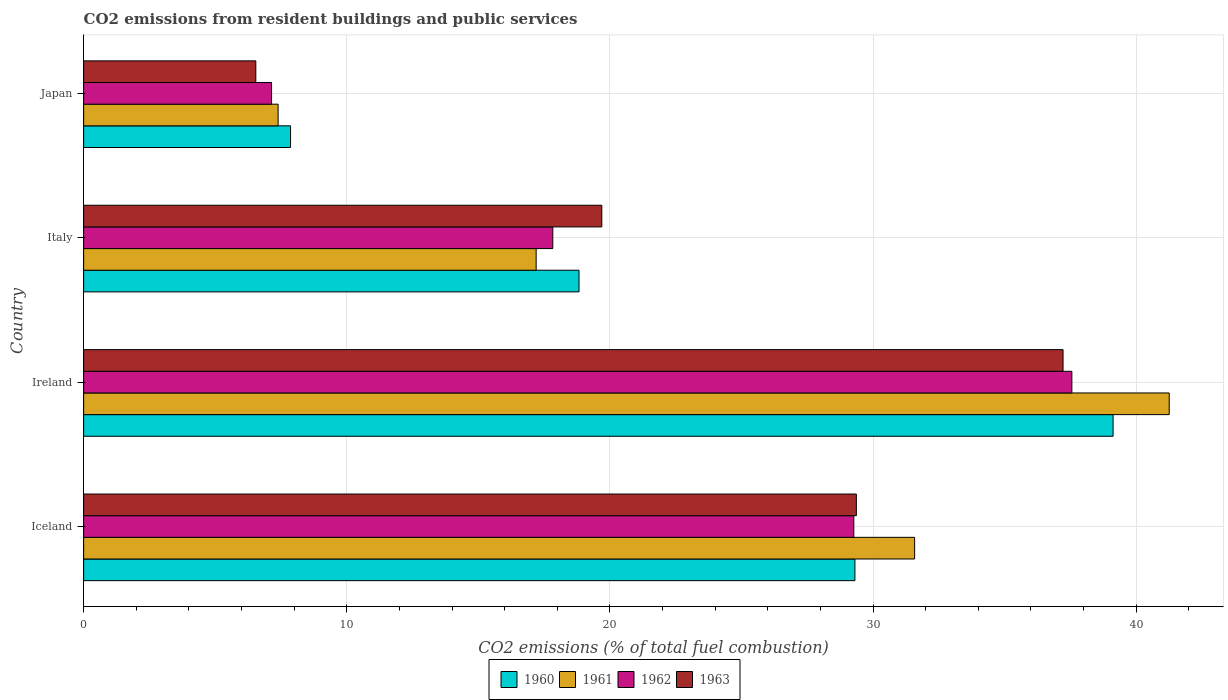How many bars are there on the 2nd tick from the bottom?
Provide a short and direct response. 4. What is the total CO2 emitted in 1962 in Japan?
Offer a terse response. 7.14. Across all countries, what is the maximum total CO2 emitted in 1962?
Offer a very short reply. 37.55. Across all countries, what is the minimum total CO2 emitted in 1962?
Provide a short and direct response. 7.14. In which country was the total CO2 emitted in 1960 maximum?
Your answer should be compact. Ireland. What is the total total CO2 emitted in 1960 in the graph?
Your answer should be very brief. 95.12. What is the difference between the total CO2 emitted in 1960 in Ireland and that in Italy?
Offer a very short reply. 20.29. What is the difference between the total CO2 emitted in 1960 in Japan and the total CO2 emitted in 1961 in Iceland?
Provide a succinct answer. -23.72. What is the average total CO2 emitted in 1961 per country?
Your response must be concise. 24.36. What is the difference between the total CO2 emitted in 1960 and total CO2 emitted in 1963 in Iceland?
Give a very brief answer. -0.05. In how many countries, is the total CO2 emitted in 1960 greater than 26 ?
Offer a terse response. 2. What is the ratio of the total CO2 emitted in 1960 in Iceland to that in Italy?
Give a very brief answer. 1.56. Is the total CO2 emitted in 1962 in Italy less than that in Japan?
Your answer should be compact. No. What is the difference between the highest and the second highest total CO2 emitted in 1962?
Your answer should be compact. 8.29. What is the difference between the highest and the lowest total CO2 emitted in 1960?
Provide a succinct answer. 31.26. Is the sum of the total CO2 emitted in 1961 in Ireland and Italy greater than the maximum total CO2 emitted in 1960 across all countries?
Ensure brevity in your answer.  Yes. Is it the case that in every country, the sum of the total CO2 emitted in 1962 and total CO2 emitted in 1961 is greater than the sum of total CO2 emitted in 1963 and total CO2 emitted in 1960?
Provide a succinct answer. No. Is it the case that in every country, the sum of the total CO2 emitted in 1961 and total CO2 emitted in 1963 is greater than the total CO2 emitted in 1962?
Your answer should be very brief. Yes. Are all the bars in the graph horizontal?
Make the answer very short. Yes. Are the values on the major ticks of X-axis written in scientific E-notation?
Offer a terse response. No. Where does the legend appear in the graph?
Provide a short and direct response. Bottom center. What is the title of the graph?
Provide a succinct answer. CO2 emissions from resident buildings and public services. What is the label or title of the X-axis?
Keep it short and to the point. CO2 emissions (% of total fuel combustion). What is the label or title of the Y-axis?
Offer a terse response. Country. What is the CO2 emissions (% of total fuel combustion) in 1960 in Iceland?
Ensure brevity in your answer.  29.31. What is the CO2 emissions (% of total fuel combustion) in 1961 in Iceland?
Ensure brevity in your answer.  31.58. What is the CO2 emissions (% of total fuel combustion) in 1962 in Iceland?
Your response must be concise. 29.27. What is the CO2 emissions (% of total fuel combustion) of 1963 in Iceland?
Offer a very short reply. 29.37. What is the CO2 emissions (% of total fuel combustion) of 1960 in Ireland?
Your answer should be compact. 39.12. What is the CO2 emissions (% of total fuel combustion) in 1961 in Ireland?
Ensure brevity in your answer.  41.25. What is the CO2 emissions (% of total fuel combustion) of 1962 in Ireland?
Ensure brevity in your answer.  37.55. What is the CO2 emissions (% of total fuel combustion) of 1963 in Ireland?
Ensure brevity in your answer.  37.22. What is the CO2 emissions (% of total fuel combustion) in 1960 in Italy?
Your answer should be very brief. 18.83. What is the CO2 emissions (% of total fuel combustion) in 1961 in Italy?
Keep it short and to the point. 17.2. What is the CO2 emissions (% of total fuel combustion) of 1962 in Italy?
Give a very brief answer. 17.83. What is the CO2 emissions (% of total fuel combustion) in 1963 in Italy?
Offer a terse response. 19.69. What is the CO2 emissions (% of total fuel combustion) in 1960 in Japan?
Ensure brevity in your answer.  7.86. What is the CO2 emissions (% of total fuel combustion) of 1961 in Japan?
Your answer should be very brief. 7.39. What is the CO2 emissions (% of total fuel combustion) of 1962 in Japan?
Offer a very short reply. 7.14. What is the CO2 emissions (% of total fuel combustion) in 1963 in Japan?
Offer a very short reply. 6.54. Across all countries, what is the maximum CO2 emissions (% of total fuel combustion) of 1960?
Your response must be concise. 39.12. Across all countries, what is the maximum CO2 emissions (% of total fuel combustion) of 1961?
Make the answer very short. 41.25. Across all countries, what is the maximum CO2 emissions (% of total fuel combustion) of 1962?
Provide a short and direct response. 37.55. Across all countries, what is the maximum CO2 emissions (% of total fuel combustion) of 1963?
Your response must be concise. 37.22. Across all countries, what is the minimum CO2 emissions (% of total fuel combustion) of 1960?
Keep it short and to the point. 7.86. Across all countries, what is the minimum CO2 emissions (% of total fuel combustion) in 1961?
Offer a very short reply. 7.39. Across all countries, what is the minimum CO2 emissions (% of total fuel combustion) of 1962?
Make the answer very short. 7.14. Across all countries, what is the minimum CO2 emissions (% of total fuel combustion) of 1963?
Your answer should be very brief. 6.54. What is the total CO2 emissions (% of total fuel combustion) of 1960 in the graph?
Your answer should be very brief. 95.12. What is the total CO2 emissions (% of total fuel combustion) in 1961 in the graph?
Ensure brevity in your answer.  97.42. What is the total CO2 emissions (% of total fuel combustion) in 1962 in the graph?
Your response must be concise. 91.79. What is the total CO2 emissions (% of total fuel combustion) in 1963 in the graph?
Your answer should be very brief. 92.82. What is the difference between the CO2 emissions (% of total fuel combustion) of 1960 in Iceland and that in Ireland?
Your response must be concise. -9.81. What is the difference between the CO2 emissions (% of total fuel combustion) of 1961 in Iceland and that in Ireland?
Provide a succinct answer. -9.67. What is the difference between the CO2 emissions (% of total fuel combustion) of 1962 in Iceland and that in Ireland?
Your answer should be compact. -8.29. What is the difference between the CO2 emissions (% of total fuel combustion) in 1963 in Iceland and that in Ireland?
Your answer should be compact. -7.85. What is the difference between the CO2 emissions (% of total fuel combustion) in 1960 in Iceland and that in Italy?
Keep it short and to the point. 10.48. What is the difference between the CO2 emissions (% of total fuel combustion) of 1961 in Iceland and that in Italy?
Offer a terse response. 14.38. What is the difference between the CO2 emissions (% of total fuel combustion) of 1962 in Iceland and that in Italy?
Offer a terse response. 11.44. What is the difference between the CO2 emissions (% of total fuel combustion) of 1963 in Iceland and that in Italy?
Make the answer very short. 9.67. What is the difference between the CO2 emissions (% of total fuel combustion) in 1960 in Iceland and that in Japan?
Offer a very short reply. 21.45. What is the difference between the CO2 emissions (% of total fuel combustion) in 1961 in Iceland and that in Japan?
Offer a terse response. 24.19. What is the difference between the CO2 emissions (% of total fuel combustion) in 1962 in Iceland and that in Japan?
Make the answer very short. 22.13. What is the difference between the CO2 emissions (% of total fuel combustion) of 1963 in Iceland and that in Japan?
Offer a very short reply. 22.82. What is the difference between the CO2 emissions (% of total fuel combustion) of 1960 in Ireland and that in Italy?
Make the answer very short. 20.29. What is the difference between the CO2 emissions (% of total fuel combustion) in 1961 in Ireland and that in Italy?
Offer a very short reply. 24.06. What is the difference between the CO2 emissions (% of total fuel combustion) of 1962 in Ireland and that in Italy?
Offer a terse response. 19.73. What is the difference between the CO2 emissions (% of total fuel combustion) of 1963 in Ireland and that in Italy?
Ensure brevity in your answer.  17.53. What is the difference between the CO2 emissions (% of total fuel combustion) in 1960 in Ireland and that in Japan?
Your answer should be very brief. 31.26. What is the difference between the CO2 emissions (% of total fuel combustion) in 1961 in Ireland and that in Japan?
Make the answer very short. 33.86. What is the difference between the CO2 emissions (% of total fuel combustion) in 1962 in Ireland and that in Japan?
Your response must be concise. 30.41. What is the difference between the CO2 emissions (% of total fuel combustion) of 1963 in Ireland and that in Japan?
Give a very brief answer. 30.68. What is the difference between the CO2 emissions (% of total fuel combustion) of 1960 in Italy and that in Japan?
Ensure brevity in your answer.  10.96. What is the difference between the CO2 emissions (% of total fuel combustion) of 1961 in Italy and that in Japan?
Keep it short and to the point. 9.81. What is the difference between the CO2 emissions (% of total fuel combustion) in 1962 in Italy and that in Japan?
Offer a terse response. 10.69. What is the difference between the CO2 emissions (% of total fuel combustion) in 1963 in Italy and that in Japan?
Offer a terse response. 13.15. What is the difference between the CO2 emissions (% of total fuel combustion) in 1960 in Iceland and the CO2 emissions (% of total fuel combustion) in 1961 in Ireland?
Provide a short and direct response. -11.94. What is the difference between the CO2 emissions (% of total fuel combustion) in 1960 in Iceland and the CO2 emissions (% of total fuel combustion) in 1962 in Ireland?
Provide a succinct answer. -8.24. What is the difference between the CO2 emissions (% of total fuel combustion) in 1960 in Iceland and the CO2 emissions (% of total fuel combustion) in 1963 in Ireland?
Provide a short and direct response. -7.91. What is the difference between the CO2 emissions (% of total fuel combustion) in 1961 in Iceland and the CO2 emissions (% of total fuel combustion) in 1962 in Ireland?
Your answer should be compact. -5.98. What is the difference between the CO2 emissions (% of total fuel combustion) in 1961 in Iceland and the CO2 emissions (% of total fuel combustion) in 1963 in Ireland?
Ensure brevity in your answer.  -5.64. What is the difference between the CO2 emissions (% of total fuel combustion) in 1962 in Iceland and the CO2 emissions (% of total fuel combustion) in 1963 in Ireland?
Ensure brevity in your answer.  -7.95. What is the difference between the CO2 emissions (% of total fuel combustion) of 1960 in Iceland and the CO2 emissions (% of total fuel combustion) of 1961 in Italy?
Offer a terse response. 12.11. What is the difference between the CO2 emissions (% of total fuel combustion) in 1960 in Iceland and the CO2 emissions (% of total fuel combustion) in 1962 in Italy?
Keep it short and to the point. 11.48. What is the difference between the CO2 emissions (% of total fuel combustion) in 1960 in Iceland and the CO2 emissions (% of total fuel combustion) in 1963 in Italy?
Your answer should be very brief. 9.62. What is the difference between the CO2 emissions (% of total fuel combustion) in 1961 in Iceland and the CO2 emissions (% of total fuel combustion) in 1962 in Italy?
Offer a very short reply. 13.75. What is the difference between the CO2 emissions (% of total fuel combustion) of 1961 in Iceland and the CO2 emissions (% of total fuel combustion) of 1963 in Italy?
Your response must be concise. 11.89. What is the difference between the CO2 emissions (% of total fuel combustion) in 1962 in Iceland and the CO2 emissions (% of total fuel combustion) in 1963 in Italy?
Provide a short and direct response. 9.58. What is the difference between the CO2 emissions (% of total fuel combustion) of 1960 in Iceland and the CO2 emissions (% of total fuel combustion) of 1961 in Japan?
Your response must be concise. 21.92. What is the difference between the CO2 emissions (% of total fuel combustion) of 1960 in Iceland and the CO2 emissions (% of total fuel combustion) of 1962 in Japan?
Offer a terse response. 22.17. What is the difference between the CO2 emissions (% of total fuel combustion) in 1960 in Iceland and the CO2 emissions (% of total fuel combustion) in 1963 in Japan?
Your answer should be compact. 22.77. What is the difference between the CO2 emissions (% of total fuel combustion) of 1961 in Iceland and the CO2 emissions (% of total fuel combustion) of 1962 in Japan?
Ensure brevity in your answer.  24.44. What is the difference between the CO2 emissions (% of total fuel combustion) of 1961 in Iceland and the CO2 emissions (% of total fuel combustion) of 1963 in Japan?
Offer a very short reply. 25.04. What is the difference between the CO2 emissions (% of total fuel combustion) of 1962 in Iceland and the CO2 emissions (% of total fuel combustion) of 1963 in Japan?
Offer a terse response. 22.73. What is the difference between the CO2 emissions (% of total fuel combustion) of 1960 in Ireland and the CO2 emissions (% of total fuel combustion) of 1961 in Italy?
Give a very brief answer. 21.92. What is the difference between the CO2 emissions (% of total fuel combustion) in 1960 in Ireland and the CO2 emissions (% of total fuel combustion) in 1962 in Italy?
Offer a very short reply. 21.29. What is the difference between the CO2 emissions (% of total fuel combustion) in 1960 in Ireland and the CO2 emissions (% of total fuel combustion) in 1963 in Italy?
Offer a very short reply. 19.43. What is the difference between the CO2 emissions (% of total fuel combustion) in 1961 in Ireland and the CO2 emissions (% of total fuel combustion) in 1962 in Italy?
Offer a terse response. 23.42. What is the difference between the CO2 emissions (% of total fuel combustion) of 1961 in Ireland and the CO2 emissions (% of total fuel combustion) of 1963 in Italy?
Offer a very short reply. 21.56. What is the difference between the CO2 emissions (% of total fuel combustion) in 1962 in Ireland and the CO2 emissions (% of total fuel combustion) in 1963 in Italy?
Your answer should be very brief. 17.86. What is the difference between the CO2 emissions (% of total fuel combustion) in 1960 in Ireland and the CO2 emissions (% of total fuel combustion) in 1961 in Japan?
Your response must be concise. 31.73. What is the difference between the CO2 emissions (% of total fuel combustion) in 1960 in Ireland and the CO2 emissions (% of total fuel combustion) in 1962 in Japan?
Provide a succinct answer. 31.98. What is the difference between the CO2 emissions (% of total fuel combustion) of 1960 in Ireland and the CO2 emissions (% of total fuel combustion) of 1963 in Japan?
Give a very brief answer. 32.58. What is the difference between the CO2 emissions (% of total fuel combustion) of 1961 in Ireland and the CO2 emissions (% of total fuel combustion) of 1962 in Japan?
Offer a very short reply. 34.11. What is the difference between the CO2 emissions (% of total fuel combustion) of 1961 in Ireland and the CO2 emissions (% of total fuel combustion) of 1963 in Japan?
Give a very brief answer. 34.71. What is the difference between the CO2 emissions (% of total fuel combustion) in 1962 in Ireland and the CO2 emissions (% of total fuel combustion) in 1963 in Japan?
Make the answer very short. 31.01. What is the difference between the CO2 emissions (% of total fuel combustion) of 1960 in Italy and the CO2 emissions (% of total fuel combustion) of 1961 in Japan?
Your answer should be compact. 11.43. What is the difference between the CO2 emissions (% of total fuel combustion) of 1960 in Italy and the CO2 emissions (% of total fuel combustion) of 1962 in Japan?
Your answer should be compact. 11.68. What is the difference between the CO2 emissions (% of total fuel combustion) in 1960 in Italy and the CO2 emissions (% of total fuel combustion) in 1963 in Japan?
Offer a very short reply. 12.28. What is the difference between the CO2 emissions (% of total fuel combustion) in 1961 in Italy and the CO2 emissions (% of total fuel combustion) in 1962 in Japan?
Offer a terse response. 10.05. What is the difference between the CO2 emissions (% of total fuel combustion) of 1961 in Italy and the CO2 emissions (% of total fuel combustion) of 1963 in Japan?
Your answer should be very brief. 10.65. What is the difference between the CO2 emissions (% of total fuel combustion) of 1962 in Italy and the CO2 emissions (% of total fuel combustion) of 1963 in Japan?
Keep it short and to the point. 11.29. What is the average CO2 emissions (% of total fuel combustion) of 1960 per country?
Provide a succinct answer. 23.78. What is the average CO2 emissions (% of total fuel combustion) of 1961 per country?
Make the answer very short. 24.36. What is the average CO2 emissions (% of total fuel combustion) in 1962 per country?
Your answer should be compact. 22.95. What is the average CO2 emissions (% of total fuel combustion) in 1963 per country?
Ensure brevity in your answer.  23.2. What is the difference between the CO2 emissions (% of total fuel combustion) in 1960 and CO2 emissions (% of total fuel combustion) in 1961 in Iceland?
Offer a terse response. -2.27. What is the difference between the CO2 emissions (% of total fuel combustion) of 1960 and CO2 emissions (% of total fuel combustion) of 1962 in Iceland?
Give a very brief answer. 0.04. What is the difference between the CO2 emissions (% of total fuel combustion) in 1960 and CO2 emissions (% of total fuel combustion) in 1963 in Iceland?
Give a very brief answer. -0.05. What is the difference between the CO2 emissions (% of total fuel combustion) of 1961 and CO2 emissions (% of total fuel combustion) of 1962 in Iceland?
Your answer should be compact. 2.31. What is the difference between the CO2 emissions (% of total fuel combustion) in 1961 and CO2 emissions (% of total fuel combustion) in 1963 in Iceland?
Your response must be concise. 2.21. What is the difference between the CO2 emissions (% of total fuel combustion) of 1962 and CO2 emissions (% of total fuel combustion) of 1963 in Iceland?
Provide a succinct answer. -0.1. What is the difference between the CO2 emissions (% of total fuel combustion) of 1960 and CO2 emissions (% of total fuel combustion) of 1961 in Ireland?
Provide a succinct answer. -2.13. What is the difference between the CO2 emissions (% of total fuel combustion) in 1960 and CO2 emissions (% of total fuel combustion) in 1962 in Ireland?
Your answer should be very brief. 1.57. What is the difference between the CO2 emissions (% of total fuel combustion) in 1960 and CO2 emissions (% of total fuel combustion) in 1963 in Ireland?
Offer a very short reply. 1.9. What is the difference between the CO2 emissions (% of total fuel combustion) in 1961 and CO2 emissions (% of total fuel combustion) in 1962 in Ireland?
Your answer should be very brief. 3.7. What is the difference between the CO2 emissions (% of total fuel combustion) of 1961 and CO2 emissions (% of total fuel combustion) of 1963 in Ireland?
Your answer should be very brief. 4.03. What is the difference between the CO2 emissions (% of total fuel combustion) in 1962 and CO2 emissions (% of total fuel combustion) in 1963 in Ireland?
Provide a succinct answer. 0.34. What is the difference between the CO2 emissions (% of total fuel combustion) in 1960 and CO2 emissions (% of total fuel combustion) in 1961 in Italy?
Offer a terse response. 1.63. What is the difference between the CO2 emissions (% of total fuel combustion) of 1960 and CO2 emissions (% of total fuel combustion) of 1963 in Italy?
Offer a very short reply. -0.87. What is the difference between the CO2 emissions (% of total fuel combustion) of 1961 and CO2 emissions (% of total fuel combustion) of 1962 in Italy?
Ensure brevity in your answer.  -0.63. What is the difference between the CO2 emissions (% of total fuel combustion) of 1961 and CO2 emissions (% of total fuel combustion) of 1963 in Italy?
Make the answer very short. -2.49. What is the difference between the CO2 emissions (% of total fuel combustion) of 1962 and CO2 emissions (% of total fuel combustion) of 1963 in Italy?
Your response must be concise. -1.86. What is the difference between the CO2 emissions (% of total fuel combustion) in 1960 and CO2 emissions (% of total fuel combustion) in 1961 in Japan?
Your response must be concise. 0.47. What is the difference between the CO2 emissions (% of total fuel combustion) of 1960 and CO2 emissions (% of total fuel combustion) of 1962 in Japan?
Offer a very short reply. 0.72. What is the difference between the CO2 emissions (% of total fuel combustion) of 1960 and CO2 emissions (% of total fuel combustion) of 1963 in Japan?
Your answer should be compact. 1.32. What is the difference between the CO2 emissions (% of total fuel combustion) in 1961 and CO2 emissions (% of total fuel combustion) in 1962 in Japan?
Ensure brevity in your answer.  0.25. What is the difference between the CO2 emissions (% of total fuel combustion) of 1961 and CO2 emissions (% of total fuel combustion) of 1963 in Japan?
Provide a short and direct response. 0.85. What is the difference between the CO2 emissions (% of total fuel combustion) of 1962 and CO2 emissions (% of total fuel combustion) of 1963 in Japan?
Ensure brevity in your answer.  0.6. What is the ratio of the CO2 emissions (% of total fuel combustion) in 1960 in Iceland to that in Ireland?
Make the answer very short. 0.75. What is the ratio of the CO2 emissions (% of total fuel combustion) of 1961 in Iceland to that in Ireland?
Provide a succinct answer. 0.77. What is the ratio of the CO2 emissions (% of total fuel combustion) of 1962 in Iceland to that in Ireland?
Your answer should be compact. 0.78. What is the ratio of the CO2 emissions (% of total fuel combustion) in 1963 in Iceland to that in Ireland?
Your answer should be compact. 0.79. What is the ratio of the CO2 emissions (% of total fuel combustion) in 1960 in Iceland to that in Italy?
Provide a short and direct response. 1.56. What is the ratio of the CO2 emissions (% of total fuel combustion) of 1961 in Iceland to that in Italy?
Keep it short and to the point. 1.84. What is the ratio of the CO2 emissions (% of total fuel combustion) in 1962 in Iceland to that in Italy?
Give a very brief answer. 1.64. What is the ratio of the CO2 emissions (% of total fuel combustion) of 1963 in Iceland to that in Italy?
Offer a very short reply. 1.49. What is the ratio of the CO2 emissions (% of total fuel combustion) in 1960 in Iceland to that in Japan?
Make the answer very short. 3.73. What is the ratio of the CO2 emissions (% of total fuel combustion) in 1961 in Iceland to that in Japan?
Your answer should be very brief. 4.27. What is the ratio of the CO2 emissions (% of total fuel combustion) in 1962 in Iceland to that in Japan?
Your response must be concise. 4.1. What is the ratio of the CO2 emissions (% of total fuel combustion) of 1963 in Iceland to that in Japan?
Offer a terse response. 4.49. What is the ratio of the CO2 emissions (% of total fuel combustion) in 1960 in Ireland to that in Italy?
Ensure brevity in your answer.  2.08. What is the ratio of the CO2 emissions (% of total fuel combustion) of 1961 in Ireland to that in Italy?
Make the answer very short. 2.4. What is the ratio of the CO2 emissions (% of total fuel combustion) in 1962 in Ireland to that in Italy?
Give a very brief answer. 2.11. What is the ratio of the CO2 emissions (% of total fuel combustion) of 1963 in Ireland to that in Italy?
Make the answer very short. 1.89. What is the ratio of the CO2 emissions (% of total fuel combustion) in 1960 in Ireland to that in Japan?
Your answer should be very brief. 4.98. What is the ratio of the CO2 emissions (% of total fuel combustion) in 1961 in Ireland to that in Japan?
Your response must be concise. 5.58. What is the ratio of the CO2 emissions (% of total fuel combustion) of 1962 in Ireland to that in Japan?
Keep it short and to the point. 5.26. What is the ratio of the CO2 emissions (% of total fuel combustion) of 1963 in Ireland to that in Japan?
Your response must be concise. 5.69. What is the ratio of the CO2 emissions (% of total fuel combustion) in 1960 in Italy to that in Japan?
Make the answer very short. 2.39. What is the ratio of the CO2 emissions (% of total fuel combustion) of 1961 in Italy to that in Japan?
Make the answer very short. 2.33. What is the ratio of the CO2 emissions (% of total fuel combustion) in 1962 in Italy to that in Japan?
Offer a terse response. 2.5. What is the ratio of the CO2 emissions (% of total fuel combustion) of 1963 in Italy to that in Japan?
Your response must be concise. 3.01. What is the difference between the highest and the second highest CO2 emissions (% of total fuel combustion) of 1960?
Give a very brief answer. 9.81. What is the difference between the highest and the second highest CO2 emissions (% of total fuel combustion) of 1961?
Make the answer very short. 9.67. What is the difference between the highest and the second highest CO2 emissions (% of total fuel combustion) of 1962?
Your answer should be compact. 8.29. What is the difference between the highest and the second highest CO2 emissions (% of total fuel combustion) in 1963?
Offer a terse response. 7.85. What is the difference between the highest and the lowest CO2 emissions (% of total fuel combustion) in 1960?
Provide a short and direct response. 31.26. What is the difference between the highest and the lowest CO2 emissions (% of total fuel combustion) of 1961?
Ensure brevity in your answer.  33.86. What is the difference between the highest and the lowest CO2 emissions (% of total fuel combustion) of 1962?
Your response must be concise. 30.41. What is the difference between the highest and the lowest CO2 emissions (% of total fuel combustion) in 1963?
Ensure brevity in your answer.  30.68. 